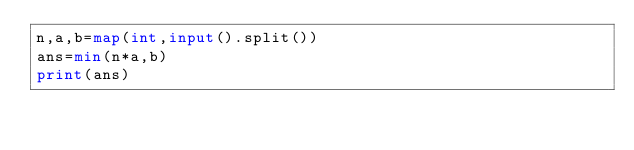<code> <loc_0><loc_0><loc_500><loc_500><_Python_>n,a,b=map(int,input().split())
ans=min(n*a,b)
print(ans)</code> 